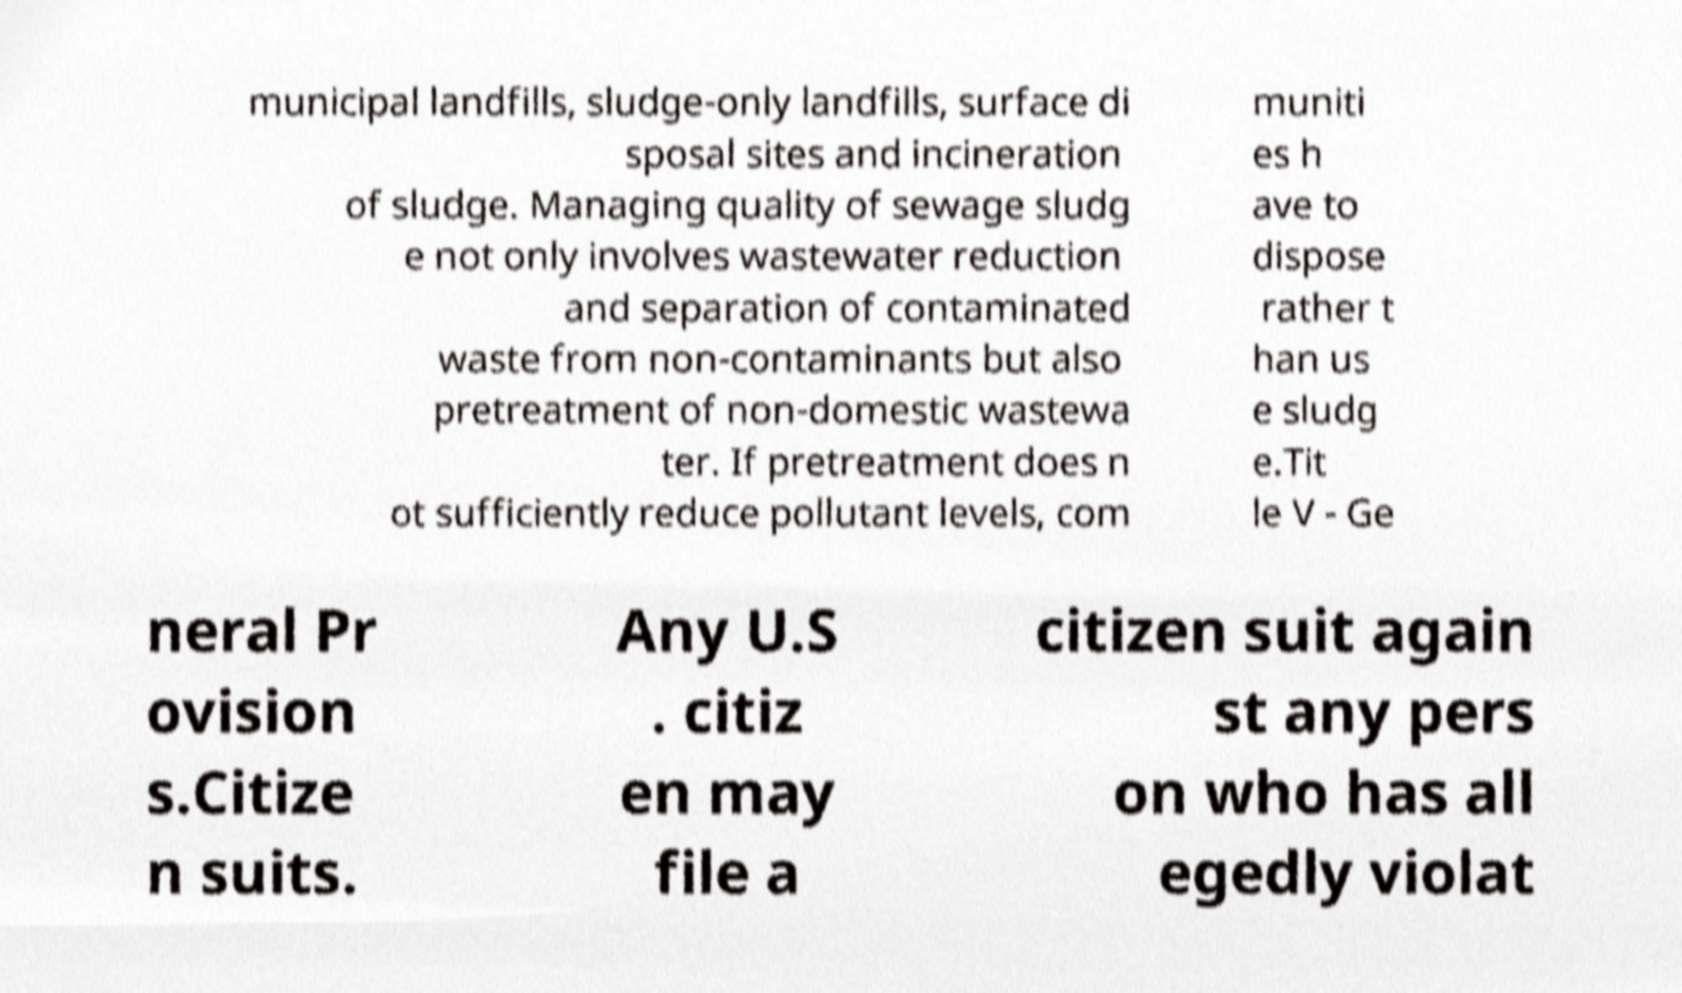Could you assist in decoding the text presented in this image and type it out clearly? municipal landfills, sludge-only landfills, surface di sposal sites and incineration of sludge. Managing quality of sewage sludg e not only involves wastewater reduction and separation of contaminated waste from non-contaminants but also pretreatment of non-domestic wastewa ter. If pretreatment does n ot sufficiently reduce pollutant levels, com muniti es h ave to dispose rather t han us e sludg e.Tit le V - Ge neral Pr ovision s.Citize n suits. Any U.S . citiz en may file a citizen suit again st any pers on who has all egedly violat 